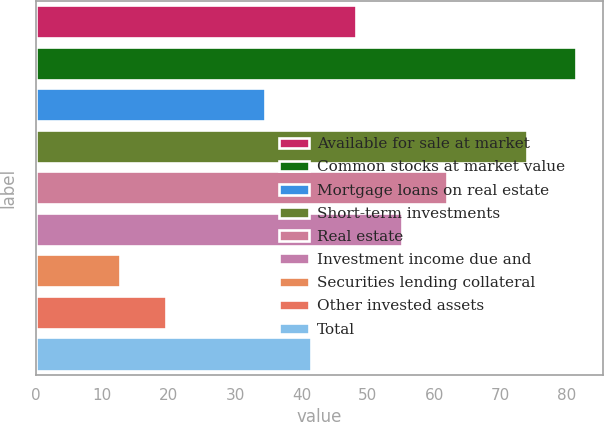Convert chart to OTSL. <chart><loc_0><loc_0><loc_500><loc_500><bar_chart><fcel>Available for sale at market<fcel>Common stocks at market value<fcel>Mortgage loans on real estate<fcel>Short-term investments<fcel>Real estate<fcel>Investment income due and<fcel>Securities lending collateral<fcel>Other invested assets<fcel>Total<nl><fcel>48.24<fcel>81.4<fcel>34.5<fcel>73.9<fcel>61.98<fcel>55.11<fcel>12.7<fcel>19.57<fcel>41.37<nl></chart> 